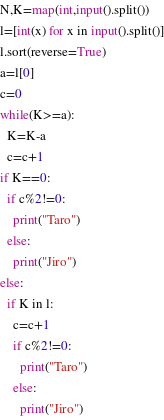Convert code to text. <code><loc_0><loc_0><loc_500><loc_500><_Python_>N,K=map(int,input().split())
l=[int(x) for x in input().split()]
l.sort(reverse=True)
a=l[0]
c=0
while(K>=a):
  K=K-a
  c=c+1
if K==0:
  if c%2!=0:
    print("Taro")
  else:
    print("Jiro")
else:
  if K in l:
    c=c+1
    if c%2!=0:
      print("Taro")
    else:
      print("Jiro")</code> 